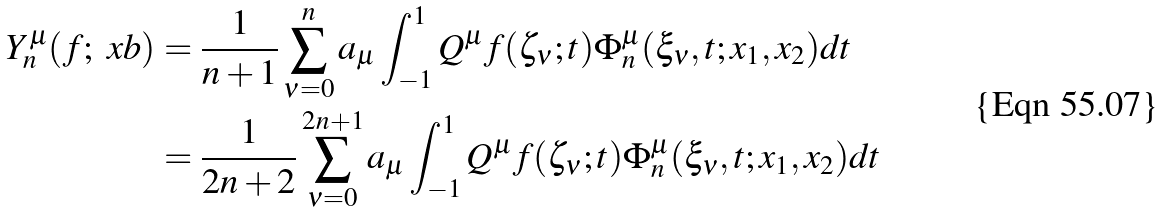<formula> <loc_0><loc_0><loc_500><loc_500>Y _ { n } ^ { \mu } ( f ; \ x b ) & = \frac { 1 } { n + 1 } \sum _ { \nu = 0 } ^ { n } a _ { \mu } \int _ { - 1 } ^ { 1 } Q ^ { \mu } f ( \zeta _ { \nu } ; t ) \Phi _ { n } ^ { \mu } ( \xi _ { \nu } , t ; x _ { 1 } , x _ { 2 } ) d t \\ & = \frac { 1 } { 2 n + 2 } \sum _ { \nu = 0 } ^ { 2 n + 1 } a _ { \mu } \int _ { - 1 } ^ { 1 } Q ^ { \mu } f ( \zeta _ { \nu } ; t ) \Phi _ { n } ^ { \mu } ( \xi _ { \nu } , t ; x _ { 1 } , x _ { 2 } ) d t</formula> 